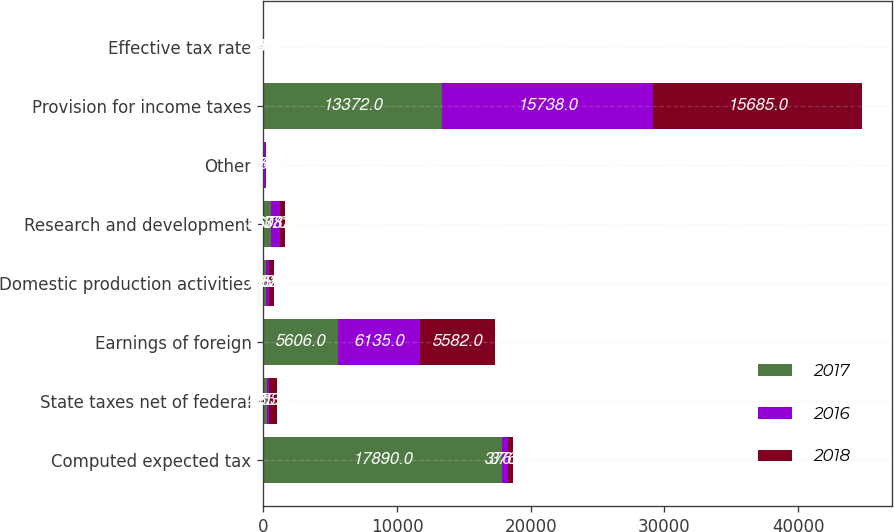Convert chart. <chart><loc_0><loc_0><loc_500><loc_500><stacked_bar_chart><ecel><fcel>Computed expected tax<fcel>State taxes net of federal<fcel>Earnings of foreign<fcel>Domestic production activities<fcel>Research and development<fcel>Other<fcel>Provision for income taxes<fcel>Effective tax rate<nl><fcel>2017<fcel>17890<fcel>271<fcel>5606<fcel>195<fcel>560<fcel>57<fcel>13372<fcel>18.3<nl><fcel>2016<fcel>376.5<fcel>185<fcel>6135<fcel>209<fcel>678<fcel>144<fcel>15738<fcel>24.6<nl><fcel>2018<fcel>376.5<fcel>553<fcel>5582<fcel>382<fcel>371<fcel>13<fcel>15685<fcel>25.6<nl></chart> 